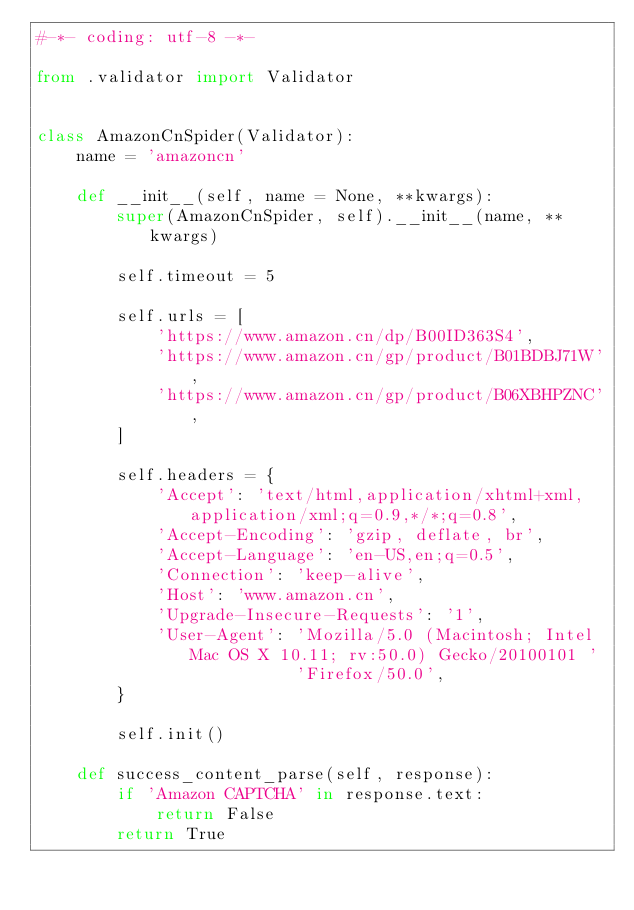<code> <loc_0><loc_0><loc_500><loc_500><_Python_>#-*- coding: utf-8 -*-

from .validator import Validator


class AmazonCnSpider(Validator):
    name = 'amazoncn'

    def __init__(self, name = None, **kwargs):
        super(AmazonCnSpider, self).__init__(name, **kwargs)

        self.timeout = 5

        self.urls = [
            'https://www.amazon.cn/dp/B00ID363S4',
            'https://www.amazon.cn/gp/product/B01BDBJ71W',
            'https://www.amazon.cn/gp/product/B06XBHPZNC',
        ]

        self.headers = {
            'Accept': 'text/html,application/xhtml+xml,application/xml;q=0.9,*/*;q=0.8',
            'Accept-Encoding': 'gzip, deflate, br',
            'Accept-Language': 'en-US,en;q=0.5',
            'Connection': 'keep-alive',
            'Host': 'www.amazon.cn',
            'Upgrade-Insecure-Requests': '1',
            'User-Agent': 'Mozilla/5.0 (Macintosh; Intel Mac OS X 10.11; rv:50.0) Gecko/20100101 '
                          'Firefox/50.0',
        }

        self.init()

    def success_content_parse(self, response):
        if 'Amazon CAPTCHA' in response.text:
            return False
        return True
        
        
        
        
</code> 